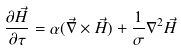Convert formula to latex. <formula><loc_0><loc_0><loc_500><loc_500>\frac { \partial \vec { H } } { \partial \tau } = \alpha ( \vec { \nabla } \times \vec { H } ) + \frac { 1 } { \sigma } \nabla ^ { 2 } \vec { H }</formula> 